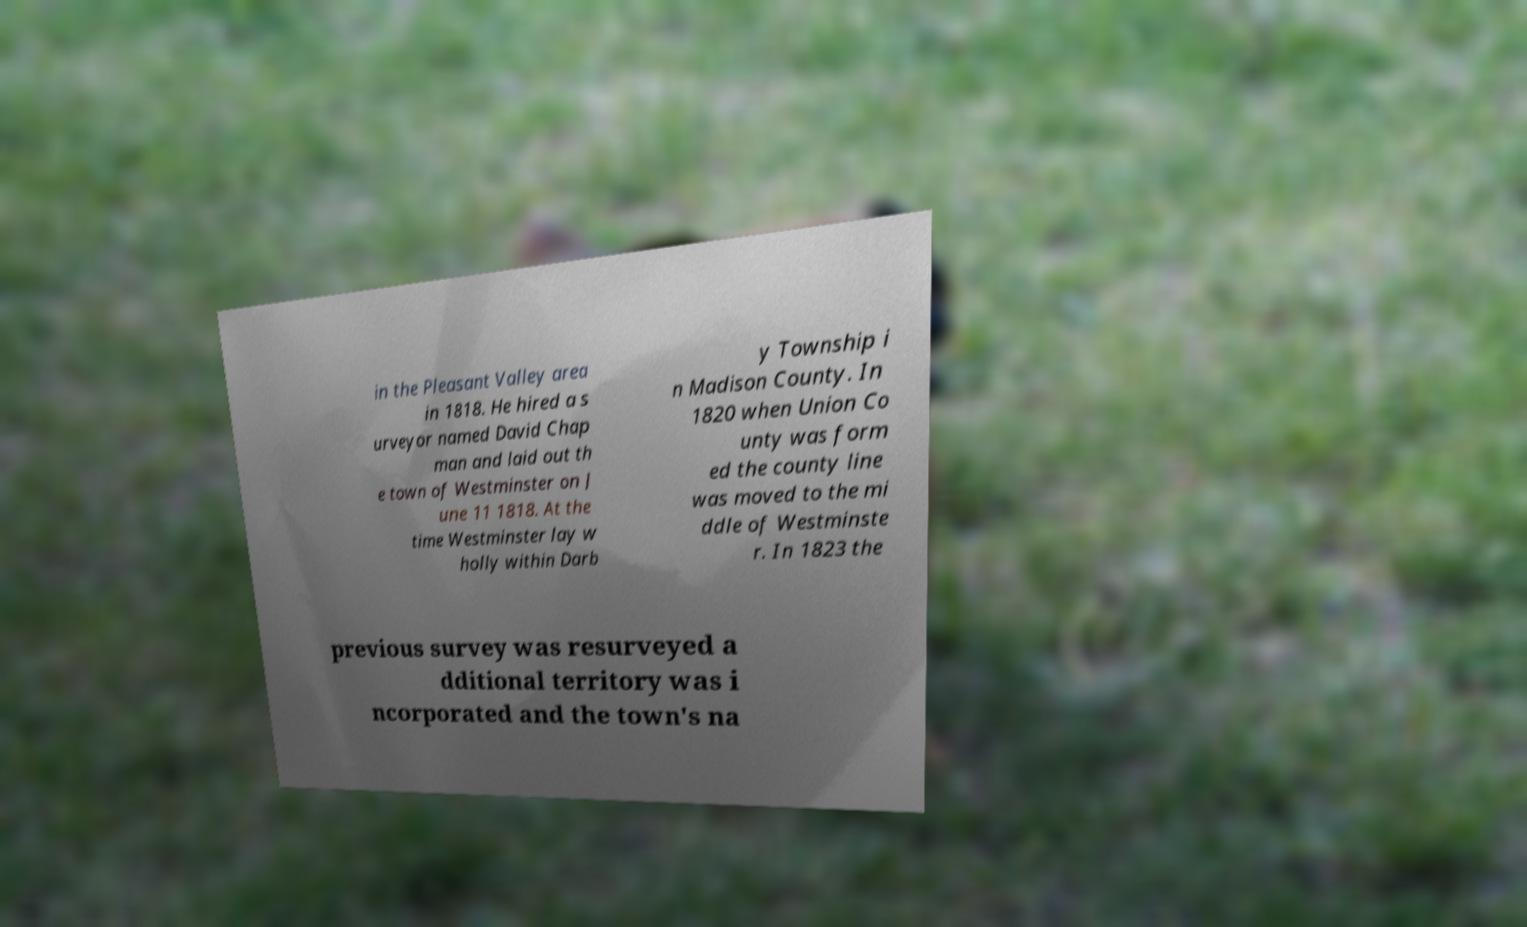What messages or text are displayed in this image? I need them in a readable, typed format. in the Pleasant Valley area in 1818. He hired a s urveyor named David Chap man and laid out th e town of Westminster on J une 11 1818. At the time Westminster lay w holly within Darb y Township i n Madison County. In 1820 when Union Co unty was form ed the county line was moved to the mi ddle of Westminste r. In 1823 the previous survey was resurveyed a dditional territory was i ncorporated and the town's na 